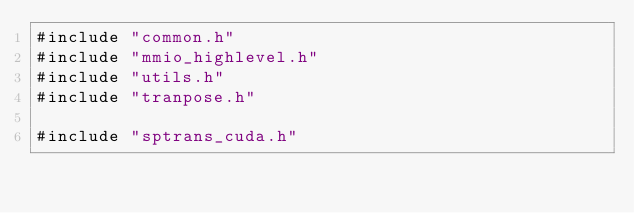<code> <loc_0><loc_0><loc_500><loc_500><_Cuda_>#include "common.h"
#include "mmio_highlevel.h"
#include "utils.h"
#include "tranpose.h"

#include "sptrans_cuda.h"</code> 